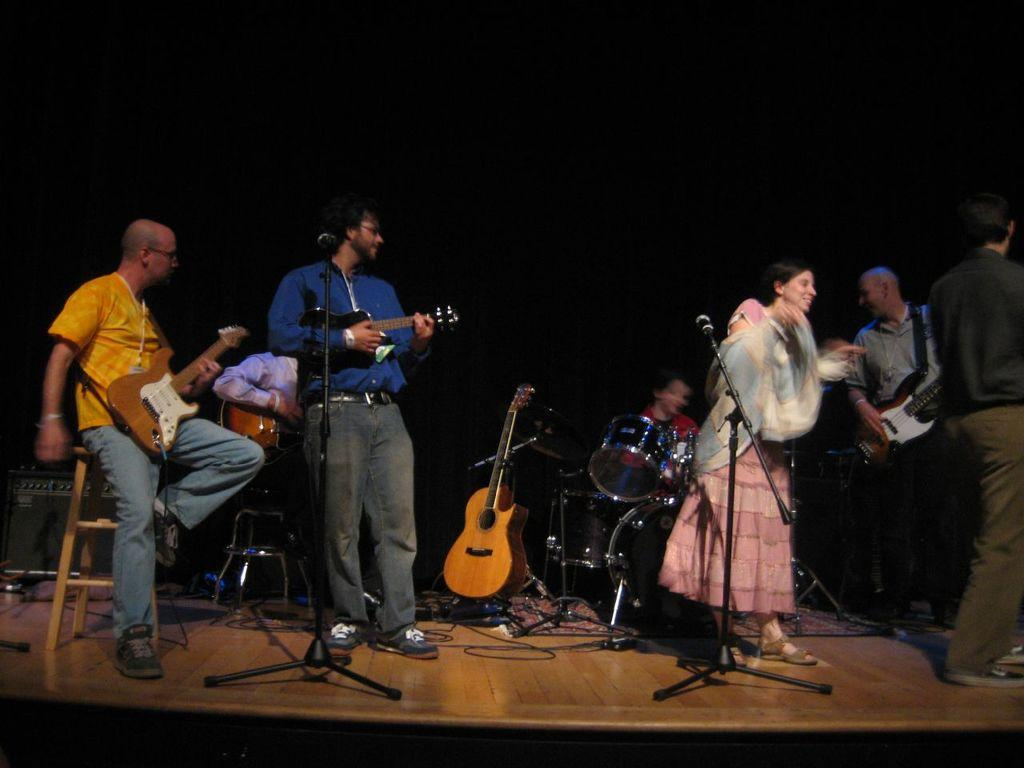What are the people in the image doing? The people in the image are playing musical instruments. What objects are present that might be used for amplifying sound? There are microphones present in the image. How many people are playing musical instruments in the image? The number of people playing musical instruments cannot be determined from the provided facts, but there are people present in the image. What type of bomb can be seen in the image? There is no bomb present in the image; the people are playing musical instruments and using microphones. 